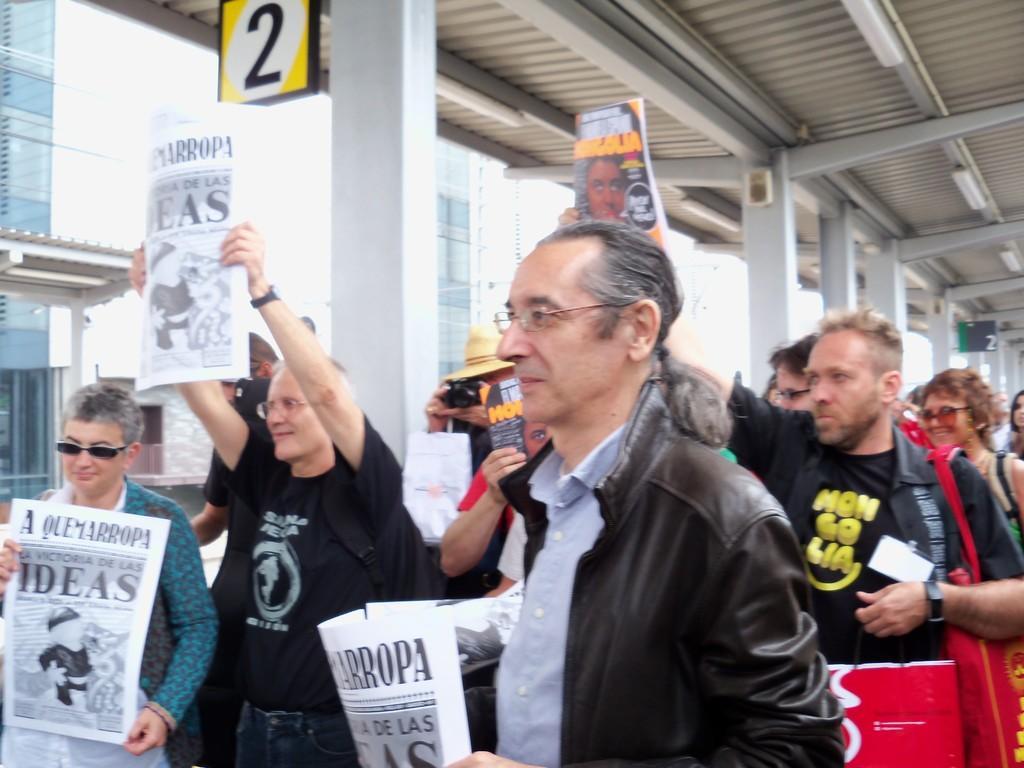Could you give a brief overview of what you see in this image? In this image I can see the group of people with different color dresses. I can see few people are holding the papers. In the background I can see the board and the wall. I can see these people are under the shed. 